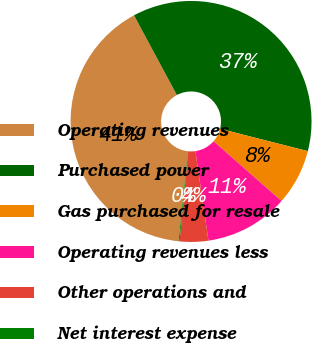Convert chart. <chart><loc_0><loc_0><loc_500><loc_500><pie_chart><fcel>Operating revenues<fcel>Purchased power<fcel>Gas purchased for resale<fcel>Operating revenues less<fcel>Other operations and<fcel>Net interest expense<nl><fcel>40.5%<fcel>36.81%<fcel>7.52%<fcel>11.21%<fcel>3.83%<fcel>0.13%<nl></chart> 